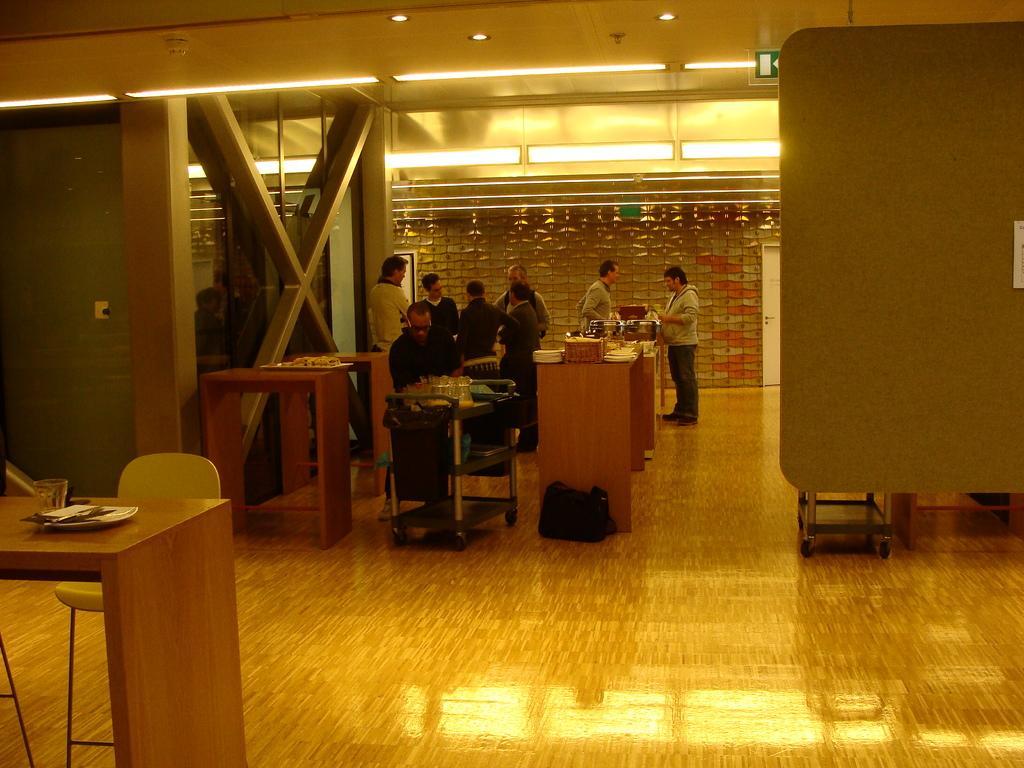Could you give a brief overview of what you see in this image? The image is inside the room. In the image there are group of people, there is man who is sitting in front of a table on table we can see some glasses. In background there are group of people who are standing and we can also see a door which is closed. On left side we can see a chair and table on table we can see a plate,glass,pillar,switch board. 